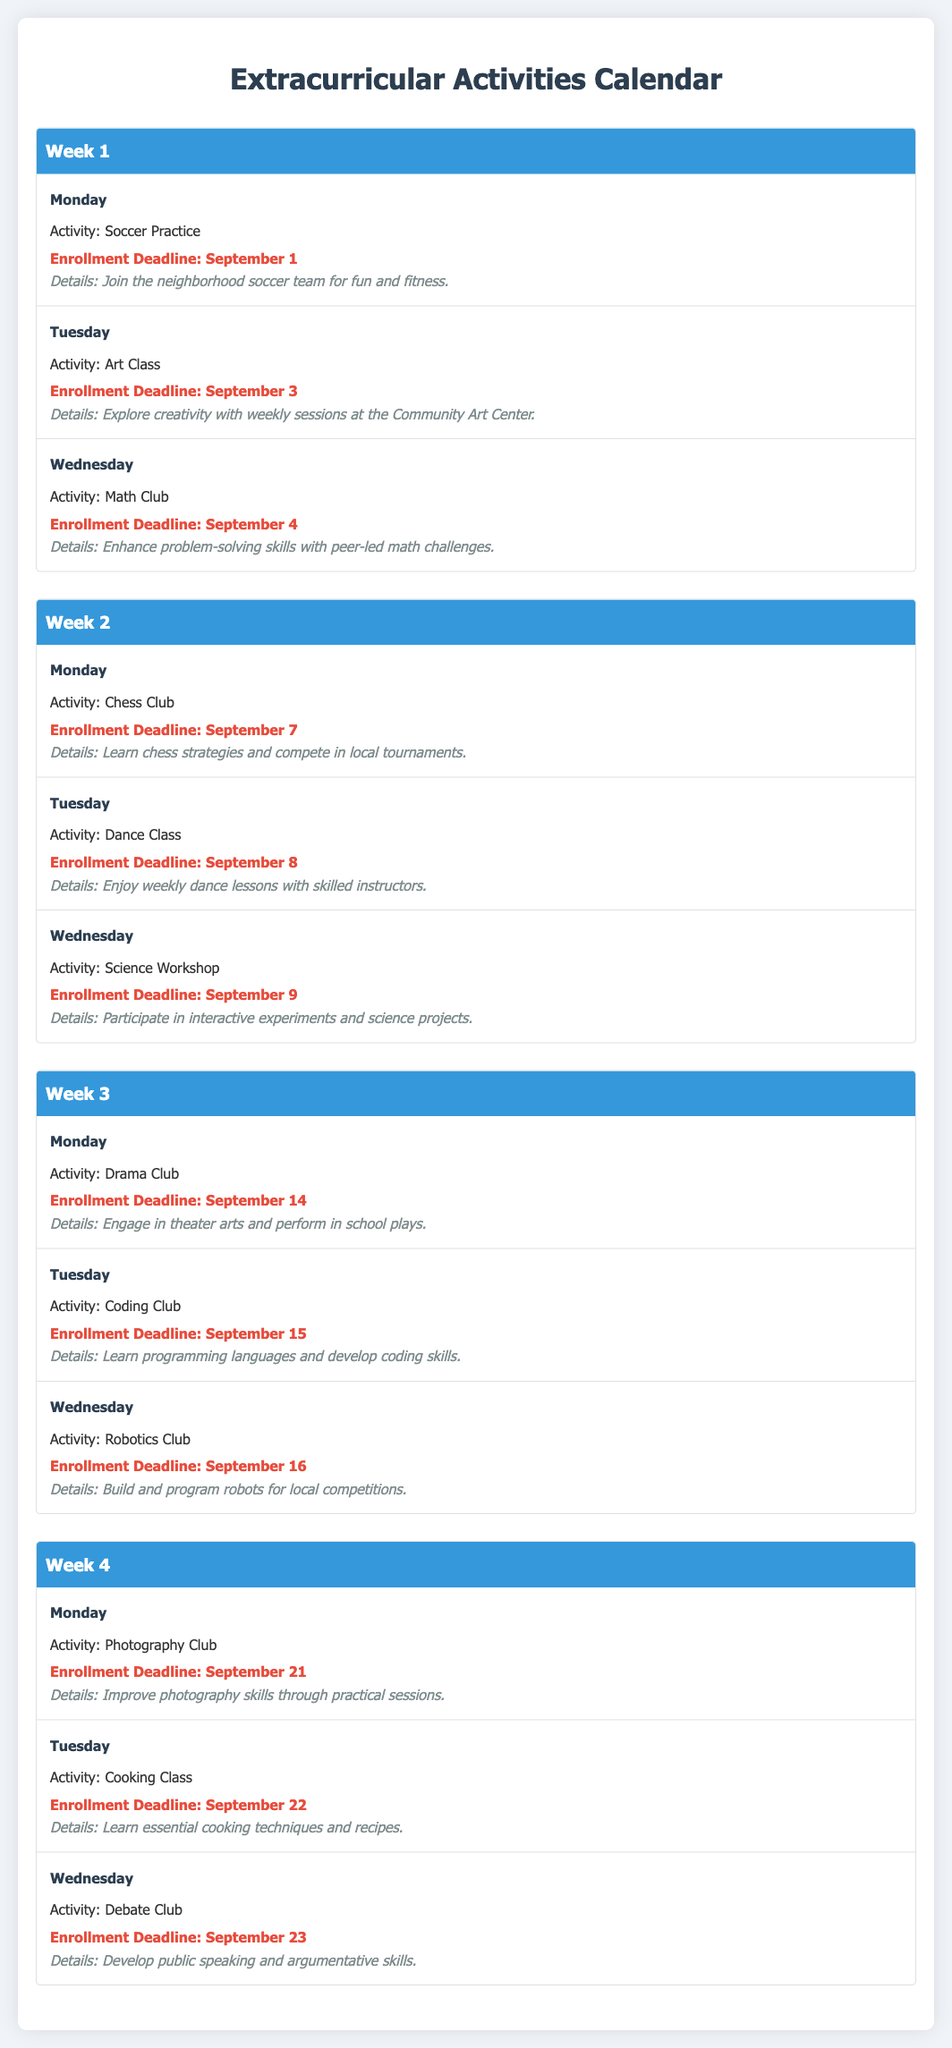What is the activity on Monday of Week 1? The activity listed for Monday of Week 1 is "Soccer Practice."
Answer: Soccer Practice What is the enrollment deadline for the Art Class? The enrollment deadline for the Art Class is September 3.
Answer: September 3 Which activity in Week 2 helps develop problem-solving skills? The activity that helps develop problem-solving skills is the "Math Club."
Answer: Math Club How many activities are scheduled on Wednesdays in Week 3? There are three activities scheduled on Wednesdays in Week 3: "Drama Club," "Coding Club," and "Robotics Club."
Answer: 3 What type of class is scheduled for Tuesday in Week 4? The type of class scheduled for Tuesday in Week 4 is a "Cooking Class."
Answer: Cooking Class Which week has a deadline for the "Chess Club"? The "Chess Club" has an enrollment deadline in Week 2.
Answer: Week 2 What is the last activity mentioned in the document? The last activity mentioned in the document is the "Debate Club."
Answer: Debate Club Which activity occurs on Wednesday of Week 1? The activity on Wednesday of Week 1 is "Math Club."
Answer: Math Club 